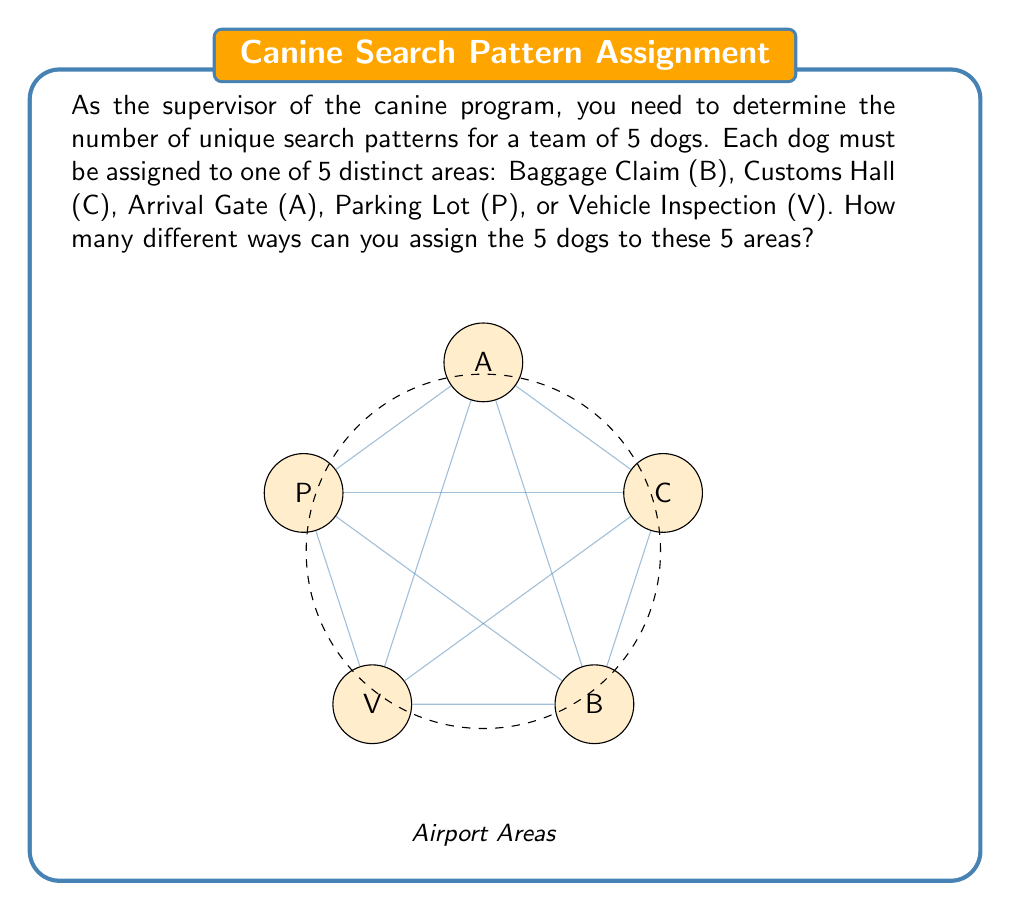Solve this math problem. Let's approach this step-by-step:

1) This problem is a perfect example of a permutation. We are arranging 5 dogs in 5 distinct positions (areas), where each dog and each area can only be used once.

2) The number of permutations of n distinct objects is given by the formula:

   $$P(n) = n!$$

   Where $n!$ represents the factorial of n.

3) In this case, we have 5 dogs and 5 areas, so $n = 5$.

4) Therefore, the number of permutations is:

   $$P(5) = 5!$$

5) Let's calculate 5!:
   
   $$5! = 5 \times 4 \times 3 \times 2 \times 1 = 120$$

6) This means there are 120 different ways to assign the 5 dogs to the 5 areas.

To illustrate this, let's consider a few examples:

- One permutation could be: (B,C,A,P,V)
- Another could be: (V,P,C,B,A)
- And another: (A,B,C,V,P)

Each of these represents a unique assignment of dogs to areas, and there are 120 such unique assignments in total.
Answer: $120$ 